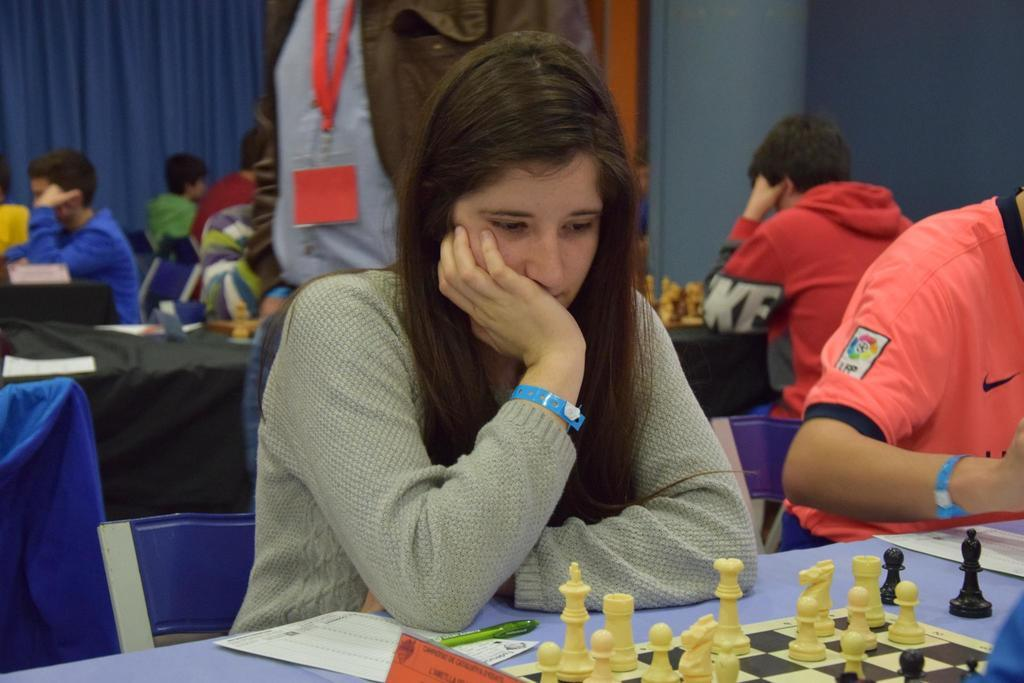What are the people in the image doing? The people in the image are playing chess. Can you describe the position of the people in the image? There are people seated and one person standing in the image. What is the standing person wearing? The standing person is wearing an ID card. What type of window treatment is visible in the image? There are curtains visible in the image. How many tin boats are floating in the water in the image? There are no tin boats or water present in the image; it features people playing chess and a standing person wearing an ID card. Is there an owl perched on the chessboard in the image? There is no owl present in the image; it only shows people playing chess and a standing person wearing an ID card. 